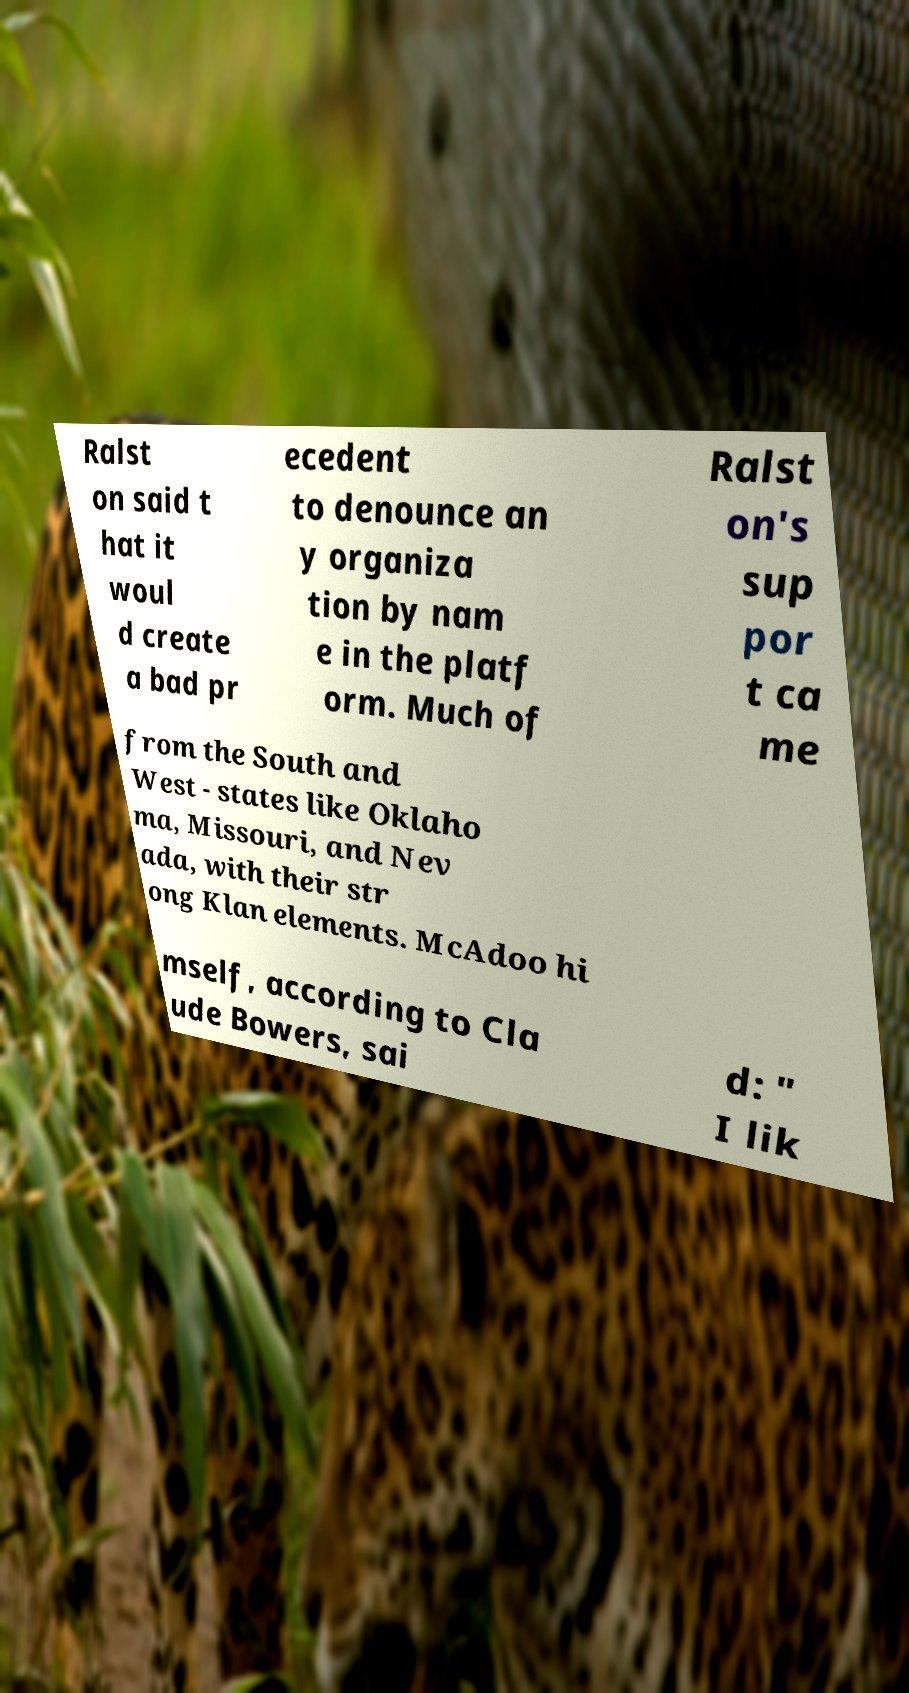Please read and relay the text visible in this image. What does it say? Ralst on said t hat it woul d create a bad pr ecedent to denounce an y organiza tion by nam e in the platf orm. Much of Ralst on's sup por t ca me from the South and West - states like Oklaho ma, Missouri, and Nev ada, with their str ong Klan elements. McAdoo hi mself, according to Cla ude Bowers, sai d: " I lik 